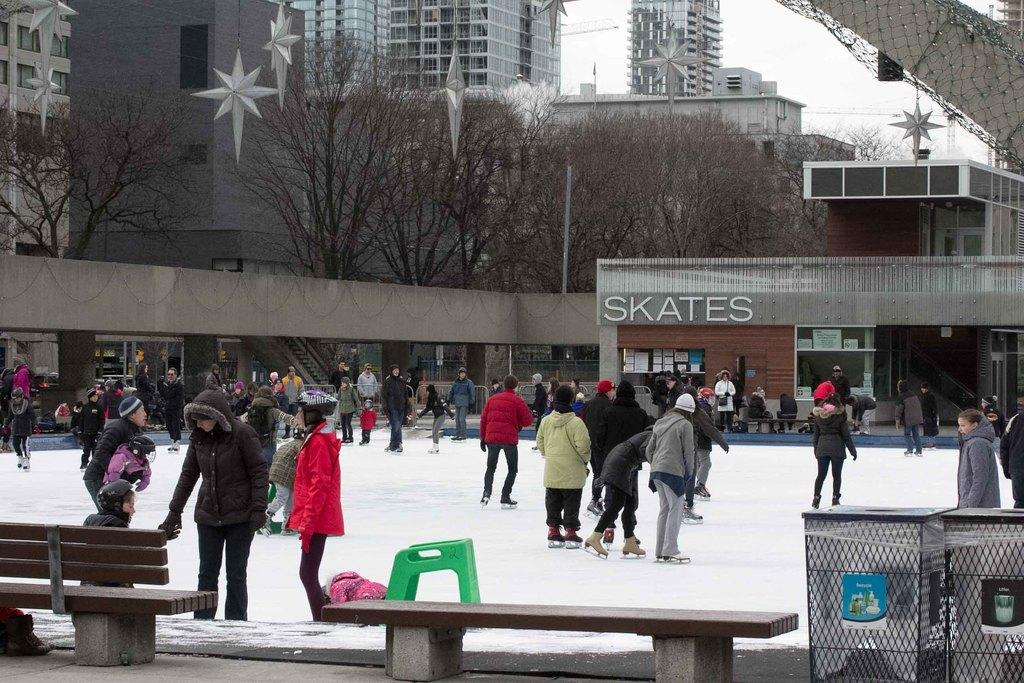What are the people in the image doing? The people in the image are skating on the snow. What can be seen in the background of the image? In the background of the image, there is a stall, glass doors, trees, and buildings. What is the color of the sky in the image? The sky is white in color. What type of crime is being committed by the grandmother in the image? There is no grandmother or crime present in the image. What is the wire used for in the image? There is no wire present in the image. 